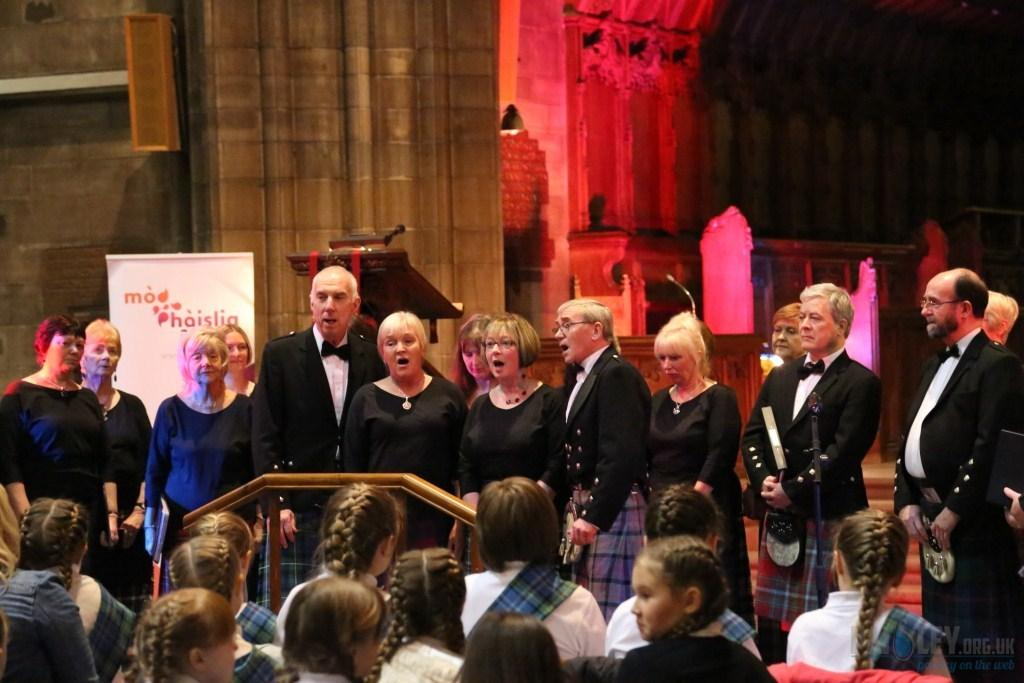How many people are in the image? There is a group of people in the image. What are some of the people doing in the image? Some of the people are standing. What can be seen in the background of the image? There is a wall, a podium, and a banner in the background of the image. What is on the podium in the image? The podium has a microphone on it. Can you see a stranger holding a flame near the machine in the image? There is no stranger, flame, or machine present in the image. 